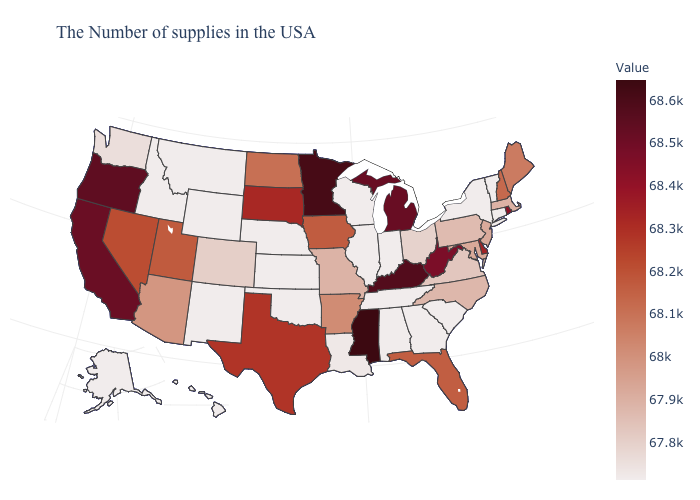Does Nevada have a higher value than Arizona?
Concise answer only. Yes. Is the legend a continuous bar?
Give a very brief answer. Yes. Does Illinois have the highest value in the USA?
Answer briefly. No. Does the map have missing data?
Give a very brief answer. No. Does Florida have a higher value than Washington?
Give a very brief answer. Yes. 